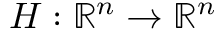Convert formula to latex. <formula><loc_0><loc_0><loc_500><loc_500>H \colon \mathbb { R } ^ { n } \rightarrow \mathbb { R } ^ { n }</formula> 